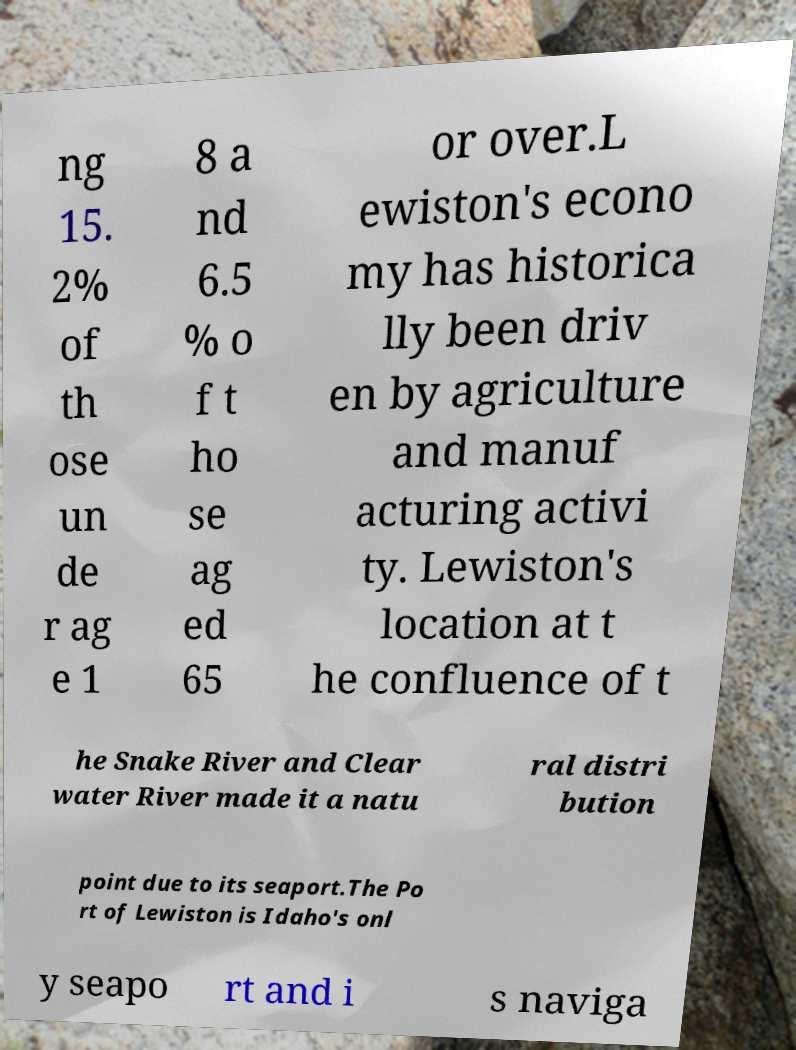There's text embedded in this image that I need extracted. Can you transcribe it verbatim? ng 15. 2% of th ose un de r ag e 1 8 a nd 6.5 % o f t ho se ag ed 65 or over.L ewiston's econo my has historica lly been driv en by agriculture and manuf acturing activi ty. Lewiston's location at t he confluence of t he Snake River and Clear water River made it a natu ral distri bution point due to its seaport.The Po rt of Lewiston is Idaho's onl y seapo rt and i s naviga 